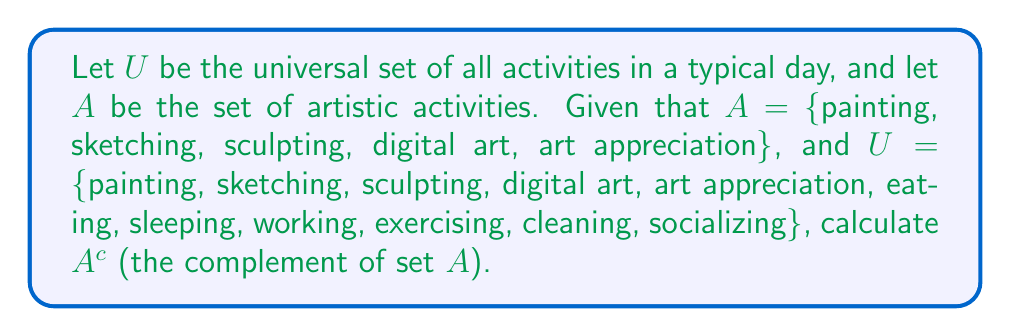What is the answer to this math problem? To solve this problem, we need to understand the concept of set complement and follow these steps:

1) The complement of a set $A$, denoted as $A^c$, is the set of all elements in the universal set $U$ that are not in $A$.

2) Mathematically, this is expressed as:
   $A^c = \{x \in U : x \notin A\}$

3) In this case, we need to identify all elements in $U$ that are not in $A$.

4) Let's list out the elements:
   $U = \{painting, sketching, sculpting, digital art, art appreciation, eating, sleeping, working, exercising, cleaning, socializing\}$
   $A = \{painting, sketching, sculpting, digital art, art appreciation\}$

5) The elements in $U$ that are not in $A$ are:
   $\{eating, sleeping, working, exercising, cleaning, socializing\}$

6) Therefore, $A^c = \{eating, sleeping, working, exercising, cleaning, socializing\}$

This set represents the non-artistic activities in a typical day, which aligns with the structured and predictable lifestyle of the given persona.
Answer: $A^c = \{eating, sleeping, working, exercising, cleaning, socializing\}$ 